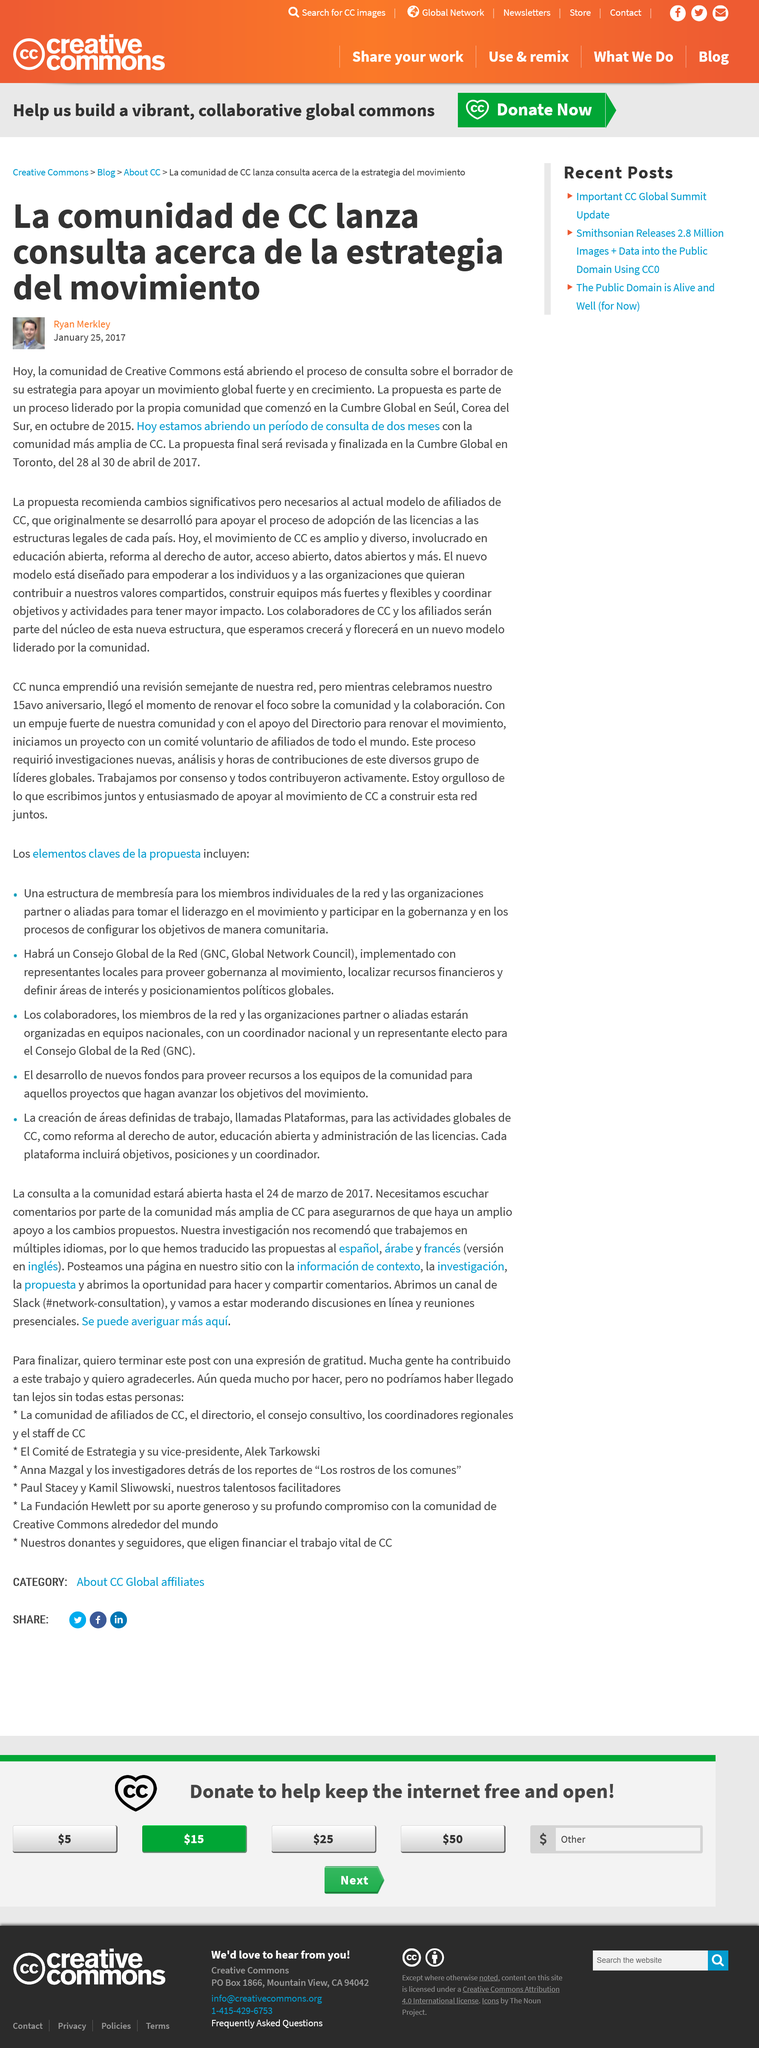Mention a couple of crucial points in this snapshot. The writer of the article is Ryan Merkley. The CC have initiated the consultation process for the development of a comprehensive strategy for a global movement that will shape the future. The finalized plan is expected to be completed in Toronto by April 28-30, 2017. 